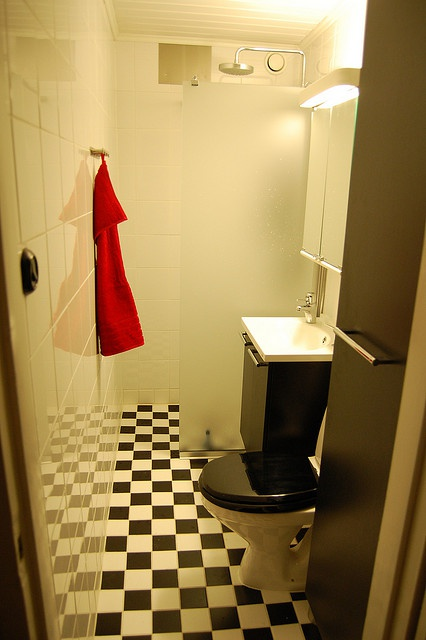Describe the objects in this image and their specific colors. I can see toilet in olive, black, and maroon tones and sink in olive, ivory, khaki, and tan tones in this image. 